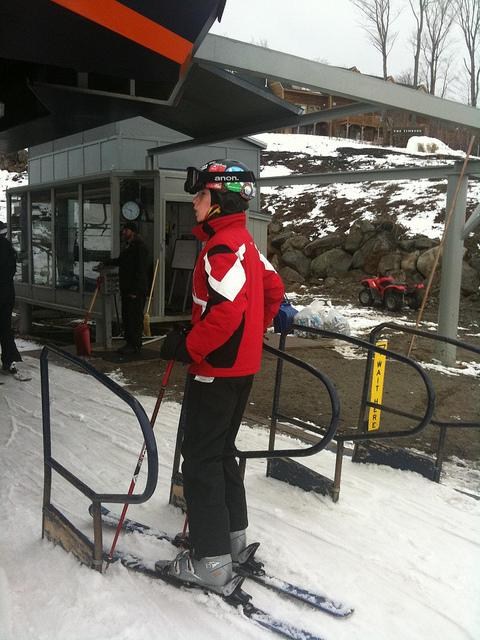What is the person in red most likely awaiting a turn for?

Choices:
A) snow blower
B) snow cat
C) ski lift
D) bus ski lift 